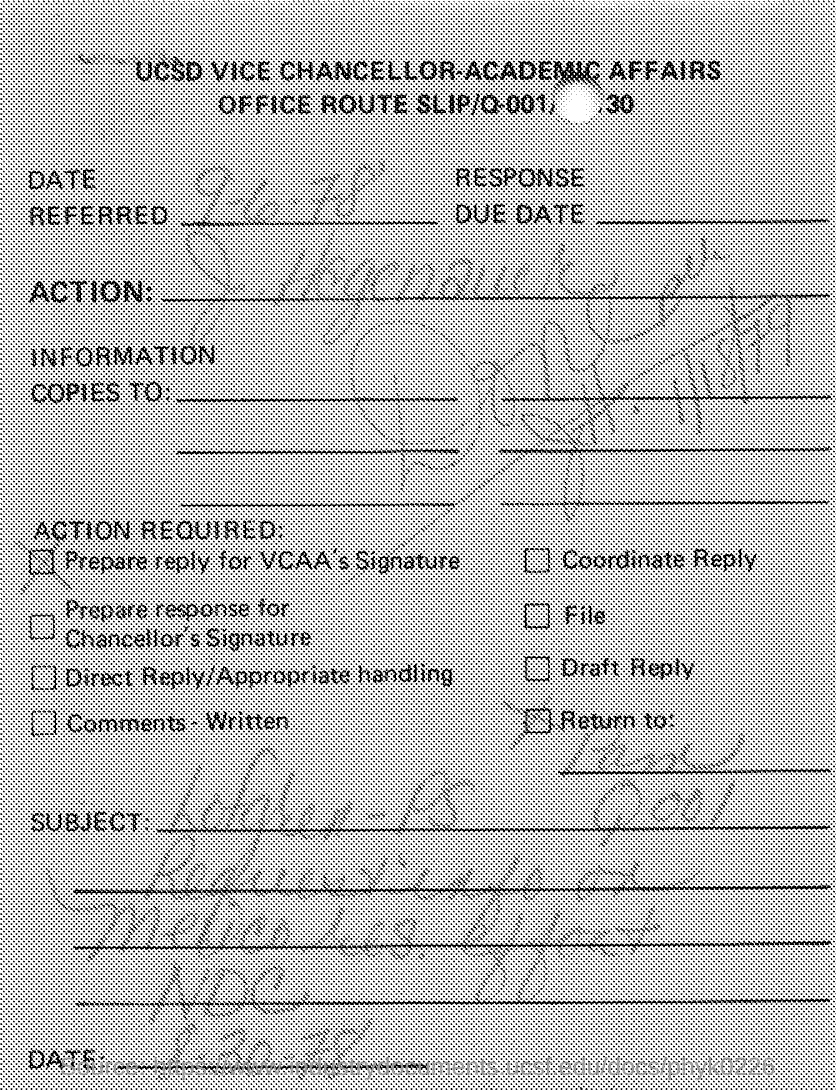Indicate a few pertinent items in this graphic. The date referred to in the document is September 6, 1978. 